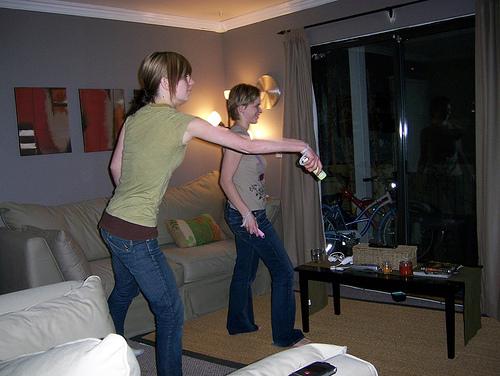How many people are standing?
Write a very short answer. 2. Is there modern art on the wall?
Quick response, please. Yes. What is reflection of?
Give a very brief answer. Woman. How many people?
Answer briefly. 2. Is the woman smiling?
Write a very short answer. Yes. 